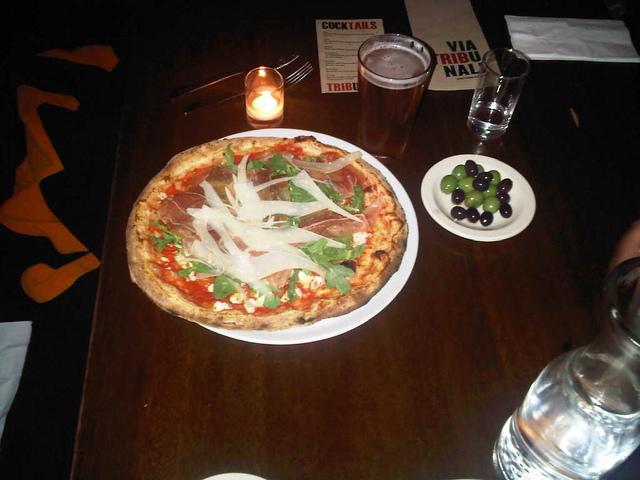Is the table  metal?
Give a very brief answer. No. Is the white napkin folded or flat?
Give a very brief answer. Flat. How many plates are on the table?
Keep it brief. 2. Is the beer glass full?
Keep it brief. Yes. What is on the pizza?
Concise answer only. Vegetables. 